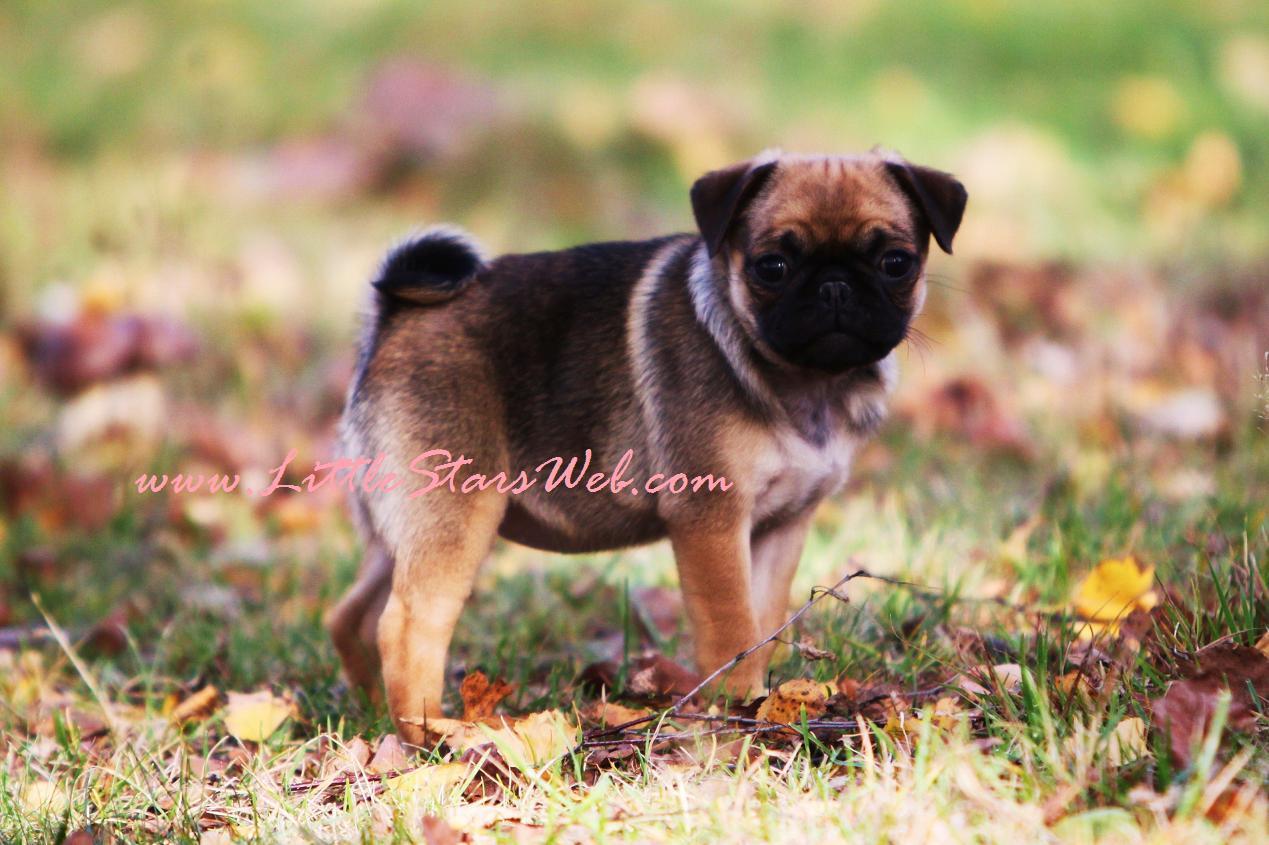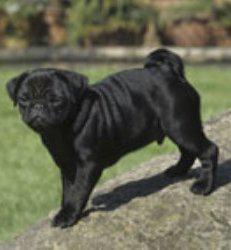The first image is the image on the left, the second image is the image on the right. Analyze the images presented: Is the assertion "There are two pups here." valid? Answer yes or no. Yes. The first image is the image on the left, the second image is the image on the right. For the images displayed, is the sentence "There are at least 3 dogs." factually correct? Answer yes or no. No. 